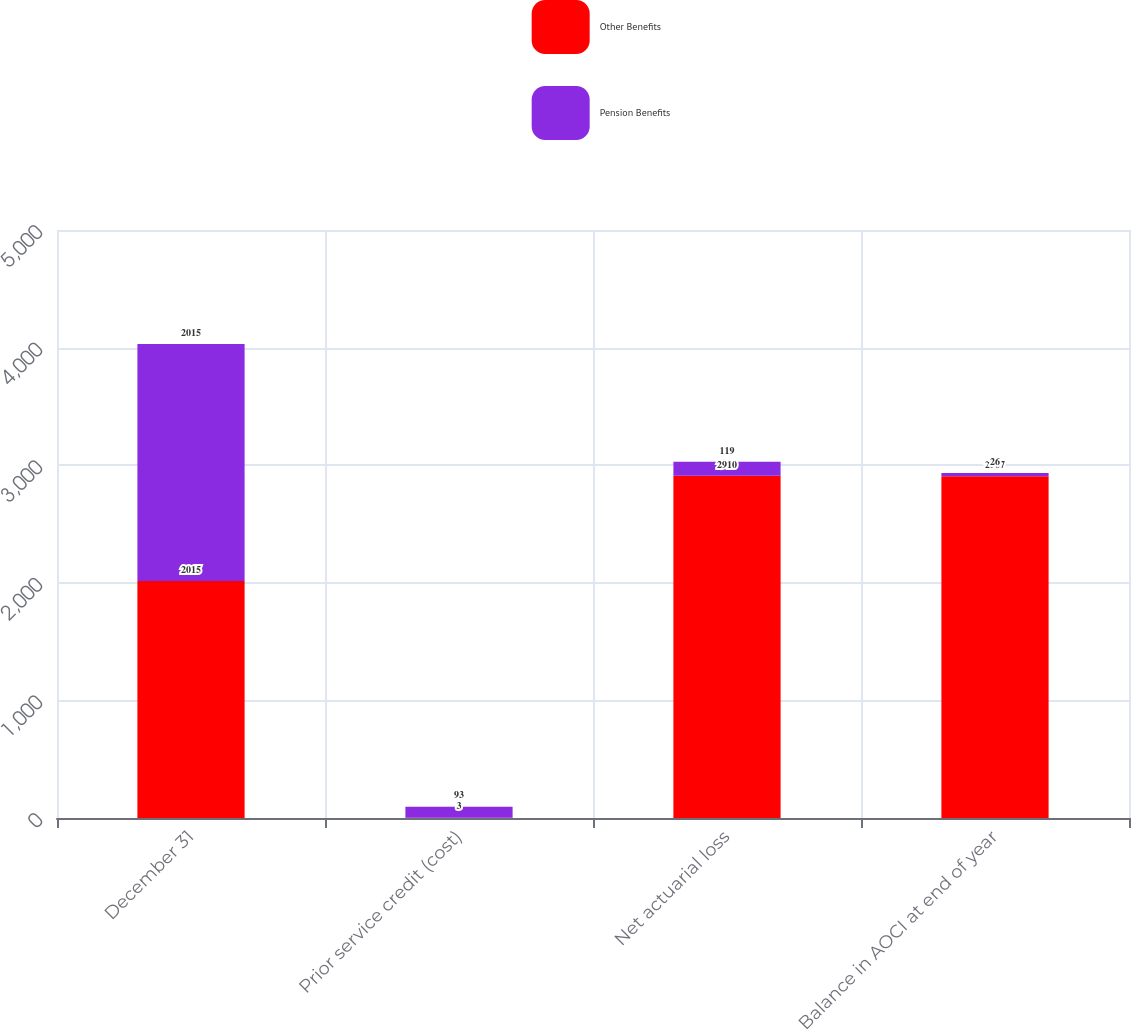<chart> <loc_0><loc_0><loc_500><loc_500><stacked_bar_chart><ecel><fcel>December 31<fcel>Prior service credit (cost)<fcel>Net actuarial loss<fcel>Balance in AOCI at end of year<nl><fcel>Other Benefits<fcel>2015<fcel>3<fcel>2910<fcel>2907<nl><fcel>Pension Benefits<fcel>2015<fcel>93<fcel>119<fcel>26<nl></chart> 